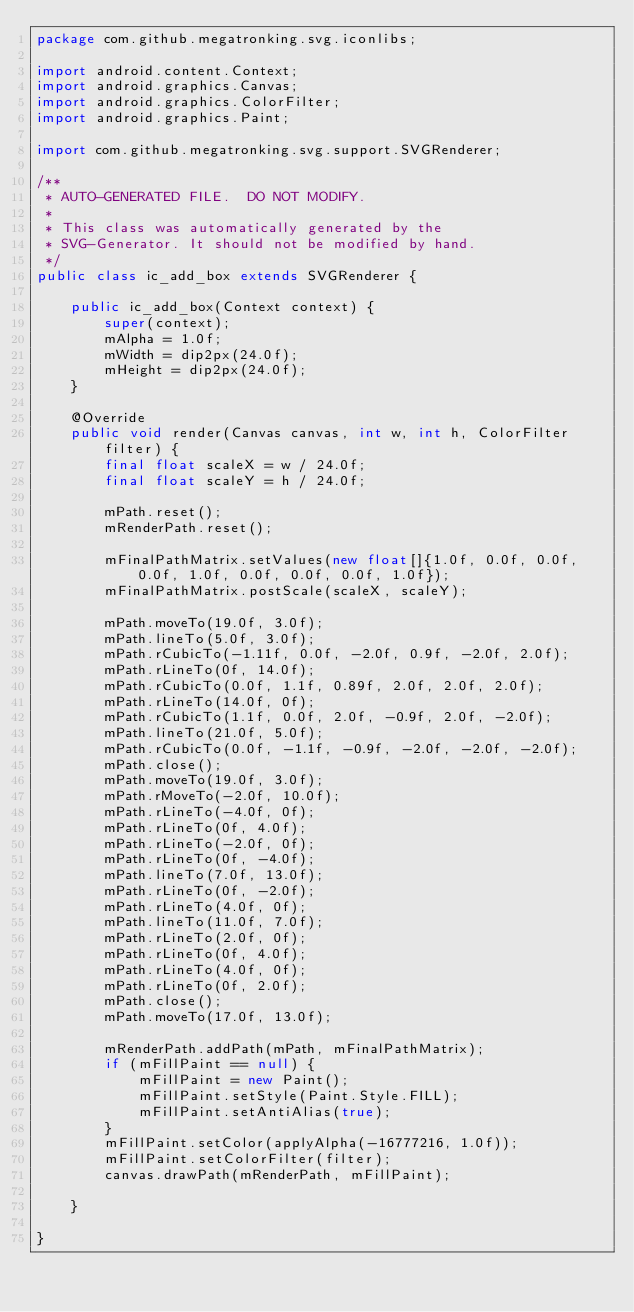Convert code to text. <code><loc_0><loc_0><loc_500><loc_500><_Java_>package com.github.megatronking.svg.iconlibs;

import android.content.Context;
import android.graphics.Canvas;
import android.graphics.ColorFilter;
import android.graphics.Paint;

import com.github.megatronking.svg.support.SVGRenderer;

/**
 * AUTO-GENERATED FILE.  DO NOT MODIFY.
 * 
 * This class was automatically generated by the
 * SVG-Generator. It should not be modified by hand.
 */
public class ic_add_box extends SVGRenderer {

    public ic_add_box(Context context) {
        super(context);
        mAlpha = 1.0f;
        mWidth = dip2px(24.0f);
        mHeight = dip2px(24.0f);
    }

    @Override
    public void render(Canvas canvas, int w, int h, ColorFilter filter) {
        final float scaleX = w / 24.0f;
        final float scaleY = h / 24.0f;
        
        mPath.reset();
        mRenderPath.reset();
        
        mFinalPathMatrix.setValues(new float[]{1.0f, 0.0f, 0.0f, 0.0f, 1.0f, 0.0f, 0.0f, 0.0f, 1.0f});
        mFinalPathMatrix.postScale(scaleX, scaleY);
        
        mPath.moveTo(19.0f, 3.0f);
        mPath.lineTo(5.0f, 3.0f);
        mPath.rCubicTo(-1.11f, 0.0f, -2.0f, 0.9f, -2.0f, 2.0f);
        mPath.rLineTo(0f, 14.0f);
        mPath.rCubicTo(0.0f, 1.1f, 0.89f, 2.0f, 2.0f, 2.0f);
        mPath.rLineTo(14.0f, 0f);
        mPath.rCubicTo(1.1f, 0.0f, 2.0f, -0.9f, 2.0f, -2.0f);
        mPath.lineTo(21.0f, 5.0f);
        mPath.rCubicTo(0.0f, -1.1f, -0.9f, -2.0f, -2.0f, -2.0f);
        mPath.close();
        mPath.moveTo(19.0f, 3.0f);
        mPath.rMoveTo(-2.0f, 10.0f);
        mPath.rLineTo(-4.0f, 0f);
        mPath.rLineTo(0f, 4.0f);
        mPath.rLineTo(-2.0f, 0f);
        mPath.rLineTo(0f, -4.0f);
        mPath.lineTo(7.0f, 13.0f);
        mPath.rLineTo(0f, -2.0f);
        mPath.rLineTo(4.0f, 0f);
        mPath.lineTo(11.0f, 7.0f);
        mPath.rLineTo(2.0f, 0f);
        mPath.rLineTo(0f, 4.0f);
        mPath.rLineTo(4.0f, 0f);
        mPath.rLineTo(0f, 2.0f);
        mPath.close();
        mPath.moveTo(17.0f, 13.0f);
        
        mRenderPath.addPath(mPath, mFinalPathMatrix);
        if (mFillPaint == null) {
            mFillPaint = new Paint();
            mFillPaint.setStyle(Paint.Style.FILL);
            mFillPaint.setAntiAlias(true);
        }
        mFillPaint.setColor(applyAlpha(-16777216, 1.0f));
        mFillPaint.setColorFilter(filter);
        canvas.drawPath(mRenderPath, mFillPaint);

    }

}</code> 